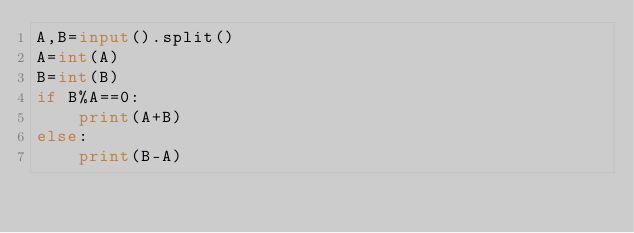Convert code to text. <code><loc_0><loc_0><loc_500><loc_500><_Python_>A,B=input().split()
A=int(A)
B=int(B)
if B%A==0:
    print(A+B)
else:
    print(B-A)
</code> 